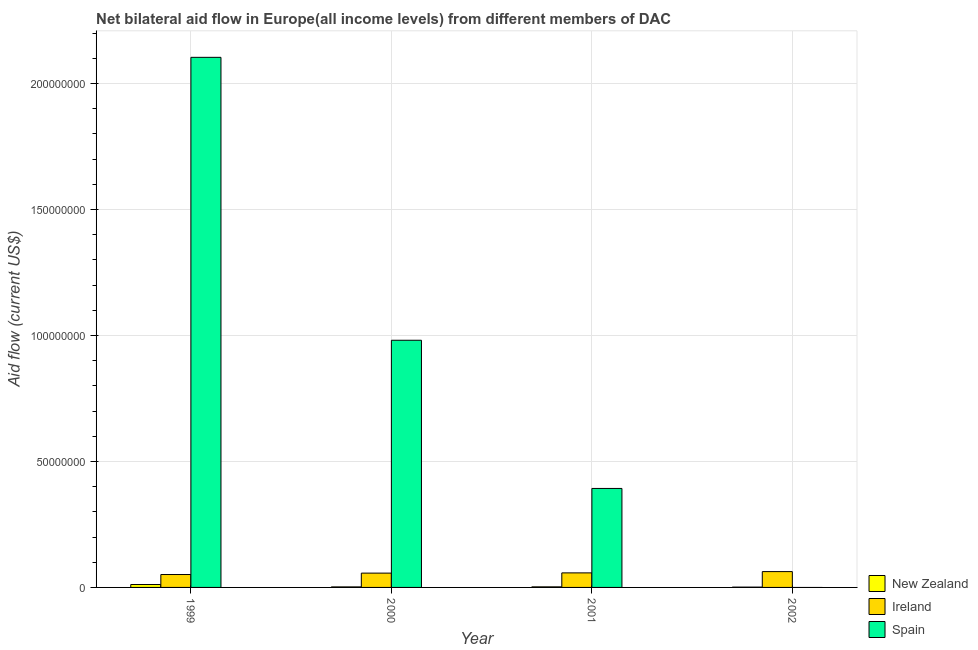How many different coloured bars are there?
Provide a short and direct response. 3. Are the number of bars on each tick of the X-axis equal?
Offer a very short reply. No. How many bars are there on the 1st tick from the left?
Your answer should be compact. 3. In how many cases, is the number of bars for a given year not equal to the number of legend labels?
Give a very brief answer. 1. What is the amount of aid provided by spain in 2001?
Make the answer very short. 3.93e+07. Across all years, what is the maximum amount of aid provided by ireland?
Your answer should be compact. 6.28e+06. Across all years, what is the minimum amount of aid provided by new zealand?
Your answer should be very brief. 1.20e+05. What is the total amount of aid provided by spain in the graph?
Offer a very short reply. 3.48e+08. What is the difference between the amount of aid provided by spain in 2000 and that in 2001?
Provide a succinct answer. 5.88e+07. What is the difference between the amount of aid provided by ireland in 2000 and the amount of aid provided by new zealand in 2002?
Give a very brief answer. -6.00e+05. What is the average amount of aid provided by spain per year?
Make the answer very short. 8.70e+07. What is the ratio of the amount of aid provided by spain in 1999 to that in 2001?
Make the answer very short. 5.36. Is the amount of aid provided by spain in 1999 less than that in 2001?
Keep it short and to the point. No. Is the difference between the amount of aid provided by ireland in 1999 and 2001 greater than the difference between the amount of aid provided by spain in 1999 and 2001?
Provide a short and direct response. No. What is the difference between the highest and the second highest amount of aid provided by ireland?
Keep it short and to the point. 5.10e+05. What is the difference between the highest and the lowest amount of aid provided by ireland?
Your response must be concise. 1.16e+06. Is the sum of the amount of aid provided by ireland in 2000 and 2001 greater than the maximum amount of aid provided by spain across all years?
Your response must be concise. Yes. Are all the bars in the graph horizontal?
Ensure brevity in your answer.  No. What is the difference between two consecutive major ticks on the Y-axis?
Your response must be concise. 5.00e+07. Are the values on the major ticks of Y-axis written in scientific E-notation?
Offer a very short reply. No. Does the graph contain any zero values?
Your answer should be very brief. Yes. Does the graph contain grids?
Provide a short and direct response. Yes. How many legend labels are there?
Offer a very short reply. 3. How are the legend labels stacked?
Ensure brevity in your answer.  Vertical. What is the title of the graph?
Offer a terse response. Net bilateral aid flow in Europe(all income levels) from different members of DAC. Does "Czech Republic" appear as one of the legend labels in the graph?
Your answer should be very brief. No. What is the label or title of the X-axis?
Provide a short and direct response. Year. What is the Aid flow (current US$) in New Zealand in 1999?
Offer a very short reply. 1.15e+06. What is the Aid flow (current US$) in Ireland in 1999?
Provide a short and direct response. 5.12e+06. What is the Aid flow (current US$) of Spain in 1999?
Offer a terse response. 2.10e+08. What is the Aid flow (current US$) in Ireland in 2000?
Keep it short and to the point. 5.68e+06. What is the Aid flow (current US$) of Spain in 2000?
Give a very brief answer. 9.81e+07. What is the Aid flow (current US$) of Ireland in 2001?
Your answer should be very brief. 5.77e+06. What is the Aid flow (current US$) in Spain in 2001?
Your answer should be compact. 3.93e+07. What is the Aid flow (current US$) of New Zealand in 2002?
Give a very brief answer. 1.20e+05. What is the Aid flow (current US$) in Ireland in 2002?
Your answer should be compact. 6.28e+06. What is the Aid flow (current US$) in Spain in 2002?
Your answer should be very brief. 0. Across all years, what is the maximum Aid flow (current US$) in New Zealand?
Your answer should be very brief. 1.15e+06. Across all years, what is the maximum Aid flow (current US$) in Ireland?
Ensure brevity in your answer.  6.28e+06. Across all years, what is the maximum Aid flow (current US$) of Spain?
Offer a terse response. 2.10e+08. Across all years, what is the minimum Aid flow (current US$) in Ireland?
Give a very brief answer. 5.12e+06. What is the total Aid flow (current US$) of New Zealand in the graph?
Give a very brief answer. 1.71e+06. What is the total Aid flow (current US$) in Ireland in the graph?
Give a very brief answer. 2.28e+07. What is the total Aid flow (current US$) in Spain in the graph?
Your response must be concise. 3.48e+08. What is the difference between the Aid flow (current US$) of New Zealand in 1999 and that in 2000?
Ensure brevity in your answer.  9.40e+05. What is the difference between the Aid flow (current US$) in Ireland in 1999 and that in 2000?
Ensure brevity in your answer.  -5.60e+05. What is the difference between the Aid flow (current US$) in Spain in 1999 and that in 2000?
Your answer should be very brief. 1.12e+08. What is the difference between the Aid flow (current US$) of New Zealand in 1999 and that in 2001?
Keep it short and to the point. 9.20e+05. What is the difference between the Aid flow (current US$) of Ireland in 1999 and that in 2001?
Give a very brief answer. -6.50e+05. What is the difference between the Aid flow (current US$) in Spain in 1999 and that in 2001?
Ensure brevity in your answer.  1.71e+08. What is the difference between the Aid flow (current US$) in New Zealand in 1999 and that in 2002?
Provide a short and direct response. 1.03e+06. What is the difference between the Aid flow (current US$) in Ireland in 1999 and that in 2002?
Keep it short and to the point. -1.16e+06. What is the difference between the Aid flow (current US$) of Ireland in 2000 and that in 2001?
Give a very brief answer. -9.00e+04. What is the difference between the Aid flow (current US$) of Spain in 2000 and that in 2001?
Keep it short and to the point. 5.88e+07. What is the difference between the Aid flow (current US$) in Ireland in 2000 and that in 2002?
Your answer should be very brief. -6.00e+05. What is the difference between the Aid flow (current US$) in New Zealand in 2001 and that in 2002?
Keep it short and to the point. 1.10e+05. What is the difference between the Aid flow (current US$) of Ireland in 2001 and that in 2002?
Make the answer very short. -5.10e+05. What is the difference between the Aid flow (current US$) of New Zealand in 1999 and the Aid flow (current US$) of Ireland in 2000?
Make the answer very short. -4.53e+06. What is the difference between the Aid flow (current US$) of New Zealand in 1999 and the Aid flow (current US$) of Spain in 2000?
Give a very brief answer. -9.70e+07. What is the difference between the Aid flow (current US$) of Ireland in 1999 and the Aid flow (current US$) of Spain in 2000?
Give a very brief answer. -9.30e+07. What is the difference between the Aid flow (current US$) of New Zealand in 1999 and the Aid flow (current US$) of Ireland in 2001?
Offer a very short reply. -4.62e+06. What is the difference between the Aid flow (current US$) of New Zealand in 1999 and the Aid flow (current US$) of Spain in 2001?
Provide a succinct answer. -3.81e+07. What is the difference between the Aid flow (current US$) in Ireland in 1999 and the Aid flow (current US$) in Spain in 2001?
Keep it short and to the point. -3.42e+07. What is the difference between the Aid flow (current US$) in New Zealand in 1999 and the Aid flow (current US$) in Ireland in 2002?
Offer a very short reply. -5.13e+06. What is the difference between the Aid flow (current US$) of New Zealand in 2000 and the Aid flow (current US$) of Ireland in 2001?
Offer a very short reply. -5.56e+06. What is the difference between the Aid flow (current US$) in New Zealand in 2000 and the Aid flow (current US$) in Spain in 2001?
Provide a short and direct response. -3.91e+07. What is the difference between the Aid flow (current US$) in Ireland in 2000 and the Aid flow (current US$) in Spain in 2001?
Offer a very short reply. -3.36e+07. What is the difference between the Aid flow (current US$) of New Zealand in 2000 and the Aid flow (current US$) of Ireland in 2002?
Provide a succinct answer. -6.07e+06. What is the difference between the Aid flow (current US$) of New Zealand in 2001 and the Aid flow (current US$) of Ireland in 2002?
Your answer should be compact. -6.05e+06. What is the average Aid flow (current US$) in New Zealand per year?
Your answer should be compact. 4.28e+05. What is the average Aid flow (current US$) of Ireland per year?
Provide a short and direct response. 5.71e+06. What is the average Aid flow (current US$) in Spain per year?
Your answer should be very brief. 8.70e+07. In the year 1999, what is the difference between the Aid flow (current US$) of New Zealand and Aid flow (current US$) of Ireland?
Provide a succinct answer. -3.97e+06. In the year 1999, what is the difference between the Aid flow (current US$) of New Zealand and Aid flow (current US$) of Spain?
Offer a very short reply. -2.09e+08. In the year 1999, what is the difference between the Aid flow (current US$) of Ireland and Aid flow (current US$) of Spain?
Your answer should be compact. -2.05e+08. In the year 2000, what is the difference between the Aid flow (current US$) of New Zealand and Aid flow (current US$) of Ireland?
Ensure brevity in your answer.  -5.47e+06. In the year 2000, what is the difference between the Aid flow (current US$) of New Zealand and Aid flow (current US$) of Spain?
Make the answer very short. -9.79e+07. In the year 2000, what is the difference between the Aid flow (current US$) in Ireland and Aid flow (current US$) in Spain?
Your answer should be compact. -9.24e+07. In the year 2001, what is the difference between the Aid flow (current US$) of New Zealand and Aid flow (current US$) of Ireland?
Your answer should be compact. -5.54e+06. In the year 2001, what is the difference between the Aid flow (current US$) of New Zealand and Aid flow (current US$) of Spain?
Your response must be concise. -3.91e+07. In the year 2001, what is the difference between the Aid flow (current US$) of Ireland and Aid flow (current US$) of Spain?
Provide a short and direct response. -3.35e+07. In the year 2002, what is the difference between the Aid flow (current US$) in New Zealand and Aid flow (current US$) in Ireland?
Your answer should be very brief. -6.16e+06. What is the ratio of the Aid flow (current US$) in New Zealand in 1999 to that in 2000?
Your response must be concise. 5.48. What is the ratio of the Aid flow (current US$) of Ireland in 1999 to that in 2000?
Your answer should be very brief. 0.9. What is the ratio of the Aid flow (current US$) in Spain in 1999 to that in 2000?
Give a very brief answer. 2.14. What is the ratio of the Aid flow (current US$) in New Zealand in 1999 to that in 2001?
Keep it short and to the point. 5. What is the ratio of the Aid flow (current US$) in Ireland in 1999 to that in 2001?
Give a very brief answer. 0.89. What is the ratio of the Aid flow (current US$) in Spain in 1999 to that in 2001?
Your response must be concise. 5.36. What is the ratio of the Aid flow (current US$) of New Zealand in 1999 to that in 2002?
Offer a very short reply. 9.58. What is the ratio of the Aid flow (current US$) of Ireland in 1999 to that in 2002?
Your response must be concise. 0.82. What is the ratio of the Aid flow (current US$) in New Zealand in 2000 to that in 2001?
Keep it short and to the point. 0.91. What is the ratio of the Aid flow (current US$) in Ireland in 2000 to that in 2001?
Ensure brevity in your answer.  0.98. What is the ratio of the Aid flow (current US$) of Spain in 2000 to that in 2001?
Ensure brevity in your answer.  2.5. What is the ratio of the Aid flow (current US$) in New Zealand in 2000 to that in 2002?
Your answer should be very brief. 1.75. What is the ratio of the Aid flow (current US$) in Ireland in 2000 to that in 2002?
Offer a terse response. 0.9. What is the ratio of the Aid flow (current US$) of New Zealand in 2001 to that in 2002?
Your answer should be compact. 1.92. What is the ratio of the Aid flow (current US$) in Ireland in 2001 to that in 2002?
Your answer should be very brief. 0.92. What is the difference between the highest and the second highest Aid flow (current US$) of New Zealand?
Offer a terse response. 9.20e+05. What is the difference between the highest and the second highest Aid flow (current US$) in Ireland?
Offer a terse response. 5.10e+05. What is the difference between the highest and the second highest Aid flow (current US$) of Spain?
Your response must be concise. 1.12e+08. What is the difference between the highest and the lowest Aid flow (current US$) in New Zealand?
Your answer should be very brief. 1.03e+06. What is the difference between the highest and the lowest Aid flow (current US$) in Ireland?
Offer a terse response. 1.16e+06. What is the difference between the highest and the lowest Aid flow (current US$) of Spain?
Provide a short and direct response. 2.10e+08. 